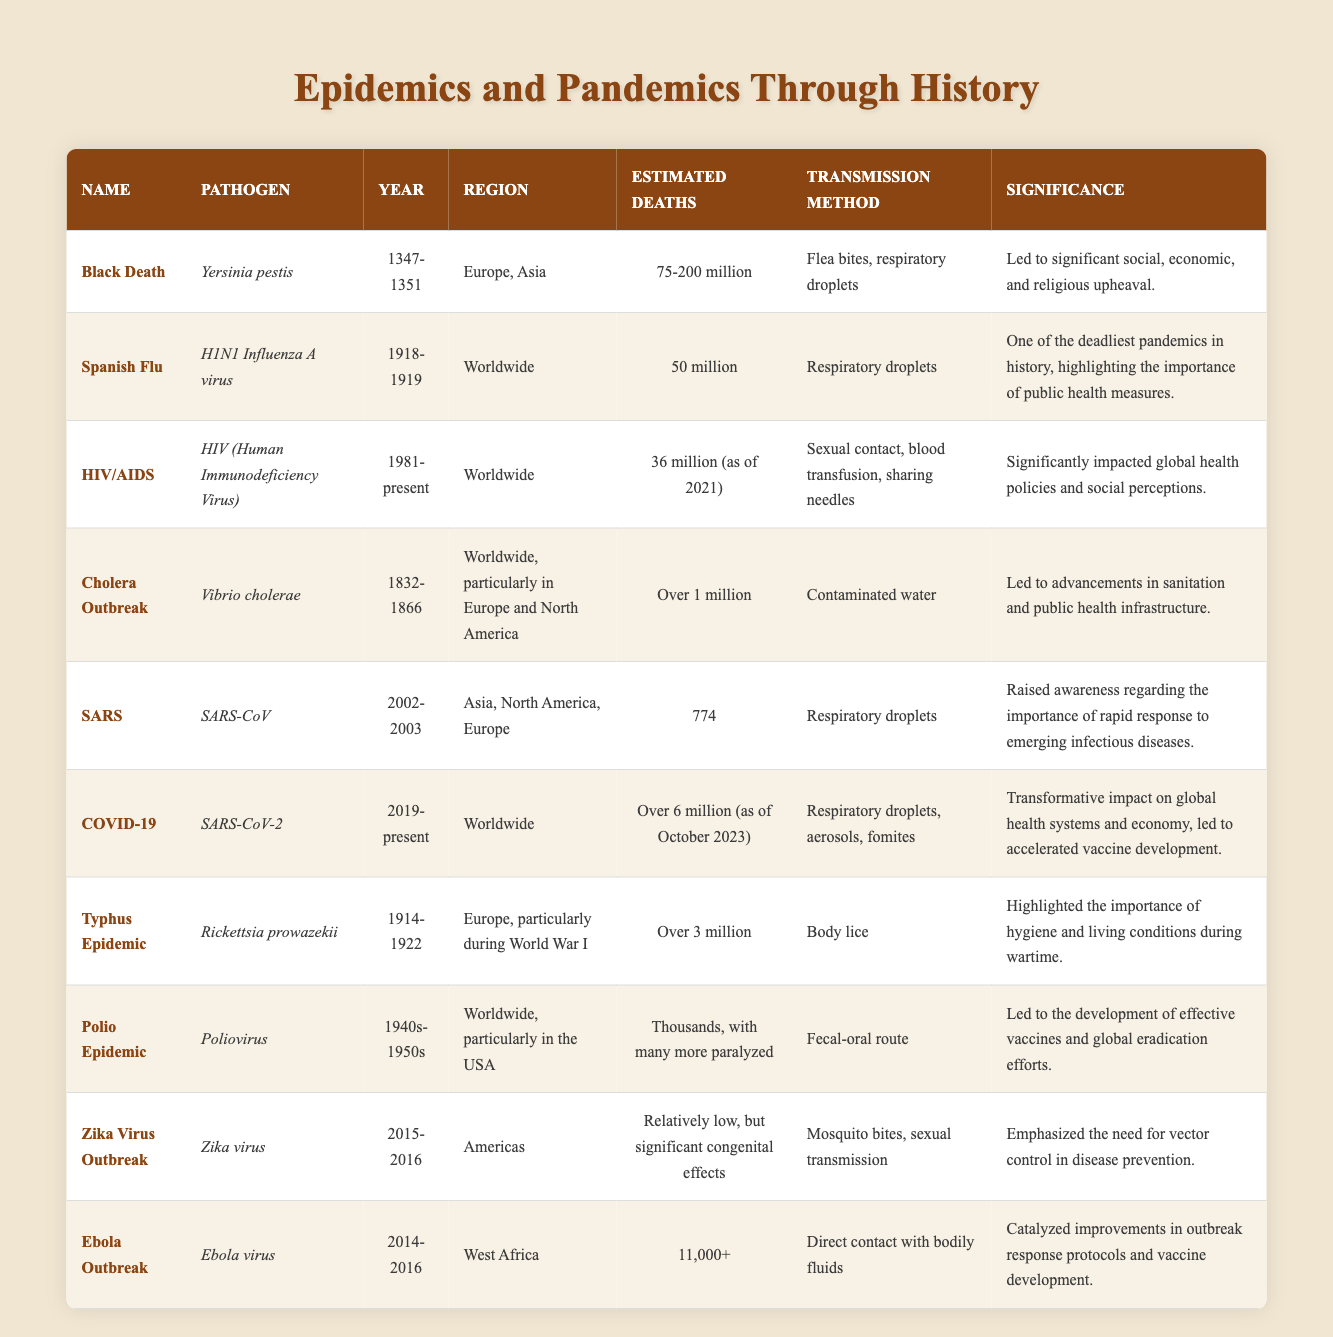What pathogen caused the Black Death? The table clearly identifies the pathogen associated with the Black Death in the "Pathogen" column, which states it is Yersinia pestis.
Answer: Yersinia pestis In what year did the Spanish Flu pandemic occur? The "Year" column for the Spanish Flu entry specifies it occurred from 1918 to 1919.
Answer: 1918-1919 How many estimated deaths were caused by the COVID-19 pandemic? The "Estimated Deaths" column shows that COVID-19 caused over 6 million deaths as of October 2023.
Answer: Over 6 million Which epidemic has the highest estimated death toll? By comparing the "Estimated Deaths" values across all entries, the Black Death, with 75-200 million estimated deaths, has the highest toll.
Answer: Black Death Did the SARS outbreak result in over 1,000 deaths? The "Estimated Deaths" column for the SARS entry shows 774 deaths, which is fewer than 1,000.
Answer: No What was the main transmission method for the cholera outbreak? The "Transmission Method" column for the Cholera Outbreak states it was contaminated water, providing a clear answer.
Answer: Contaminated water Which epidemic occurred most recently according to the table? When evaluating the "Year" column, the COVID-19 pandemic is listed as ongoing (2019-present), making it the most recent epidemic.
Answer: COVID-19 How many epidemics listed occurred between 1940 and 1950? By reviewing the "Year" column, the Polio Epidemic occurred in the 1940s-1950s, resulting in one epidemic in this range.
Answer: 1 What was the significance of the HIV/AIDS epidemic according to the table? The entry for HIV/AIDS includes a "Significance" column that states it significantly impacted global health policies and social perceptions.
Answer: Significantly impacted global health policies and social perceptions 